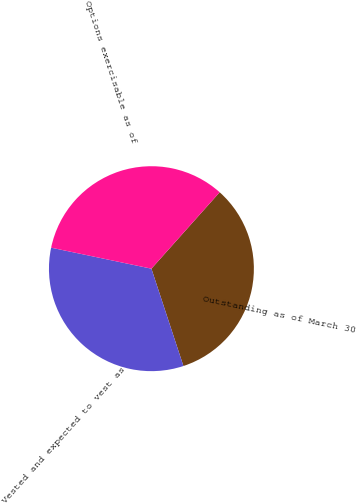Convert chart. <chart><loc_0><loc_0><loc_500><loc_500><pie_chart><fcel>Outstanding as of March 30<fcel>Vested and expected to vest as<fcel>Options exercisable as of<nl><fcel>33.34%<fcel>33.34%<fcel>33.31%<nl></chart> 